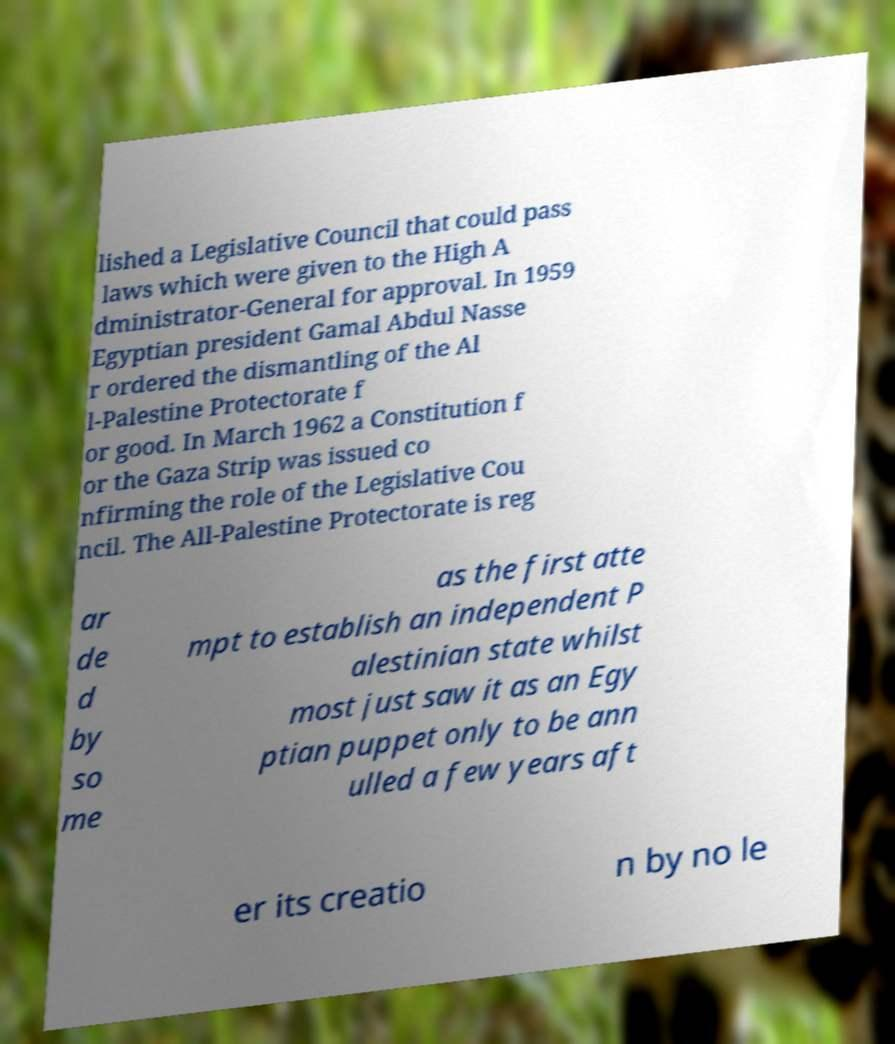For documentation purposes, I need the text within this image transcribed. Could you provide that? lished a Legislative Council that could pass laws which were given to the High A dministrator-General for approval. In 1959 Egyptian president Gamal Abdul Nasse r ordered the dismantling of the Al l-Palestine Protectorate f or good. In March 1962 a Constitution f or the Gaza Strip was issued co nfirming the role of the Legislative Cou ncil. The All-Palestine Protectorate is reg ar de d by so me as the first atte mpt to establish an independent P alestinian state whilst most just saw it as an Egy ptian puppet only to be ann ulled a few years aft er its creatio n by no le 